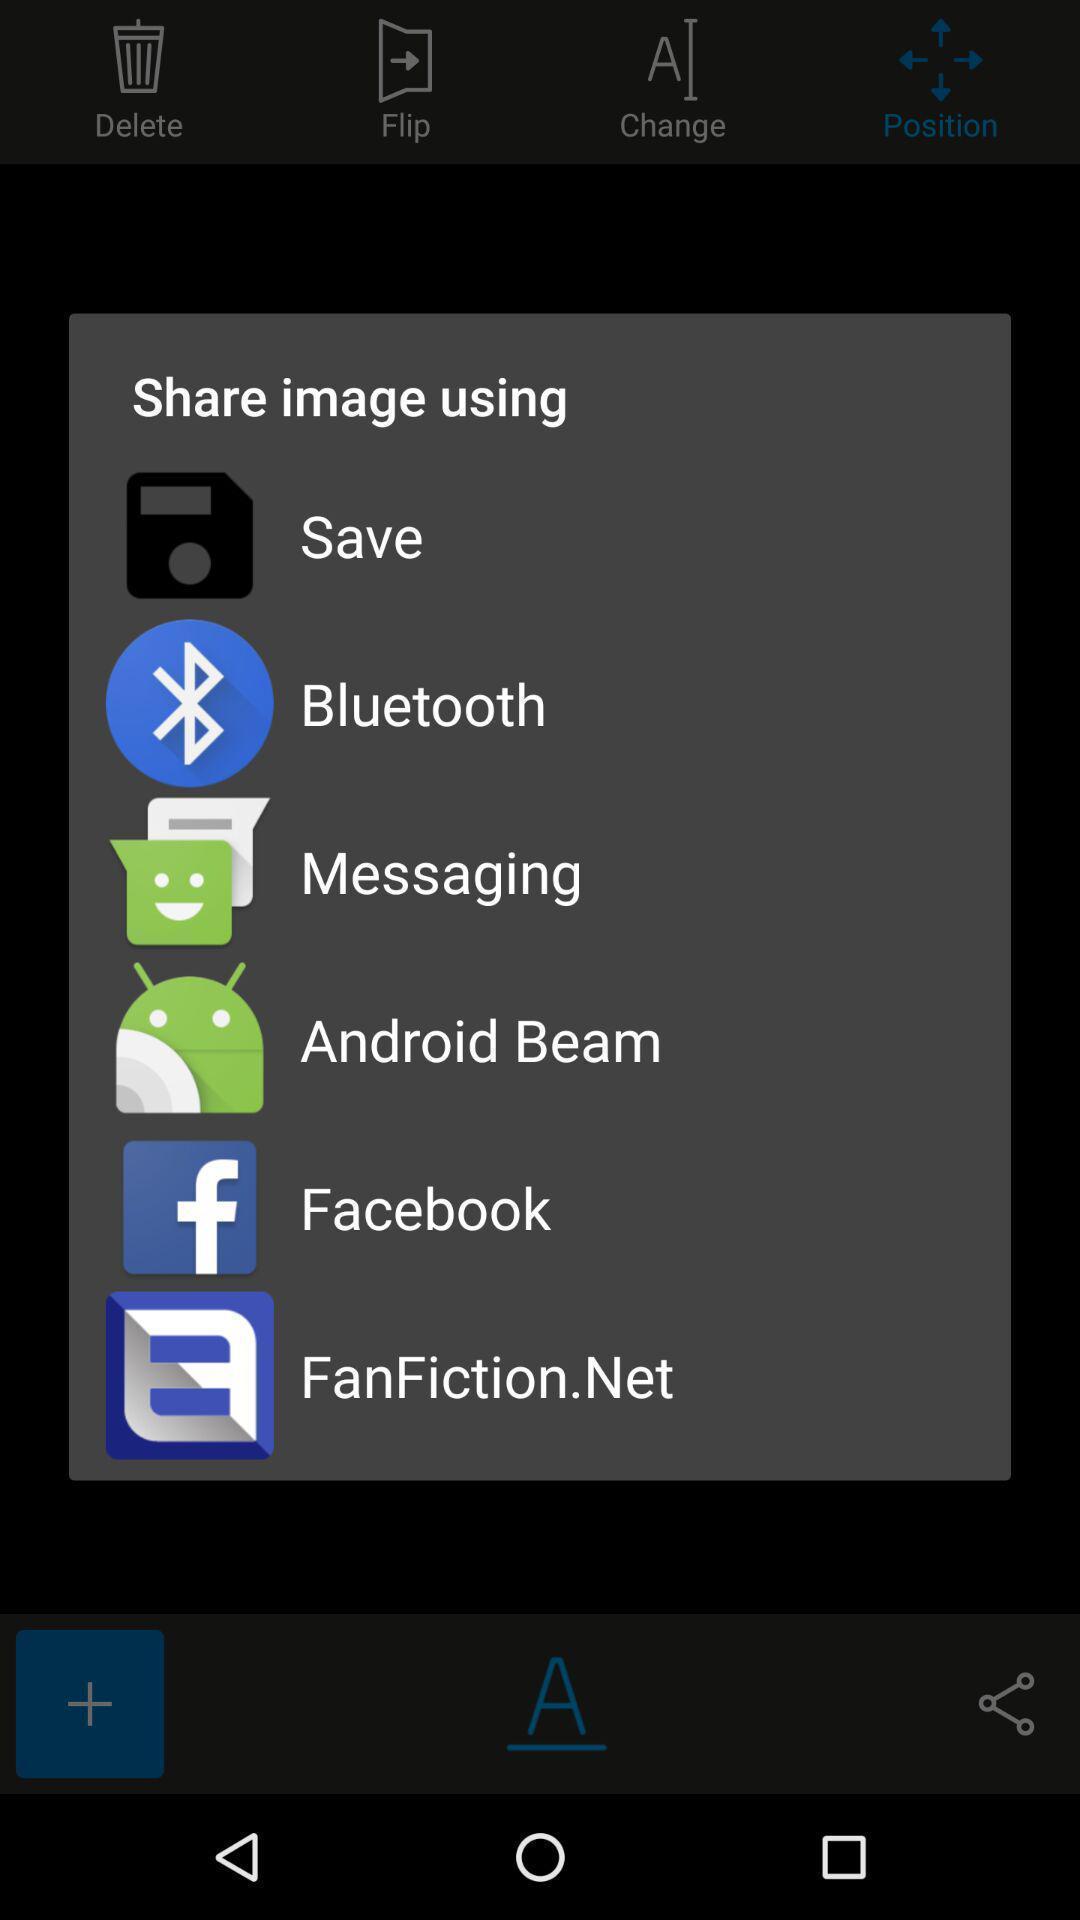Give me a narrative description of this picture. Pop-up showing various applications to share. 